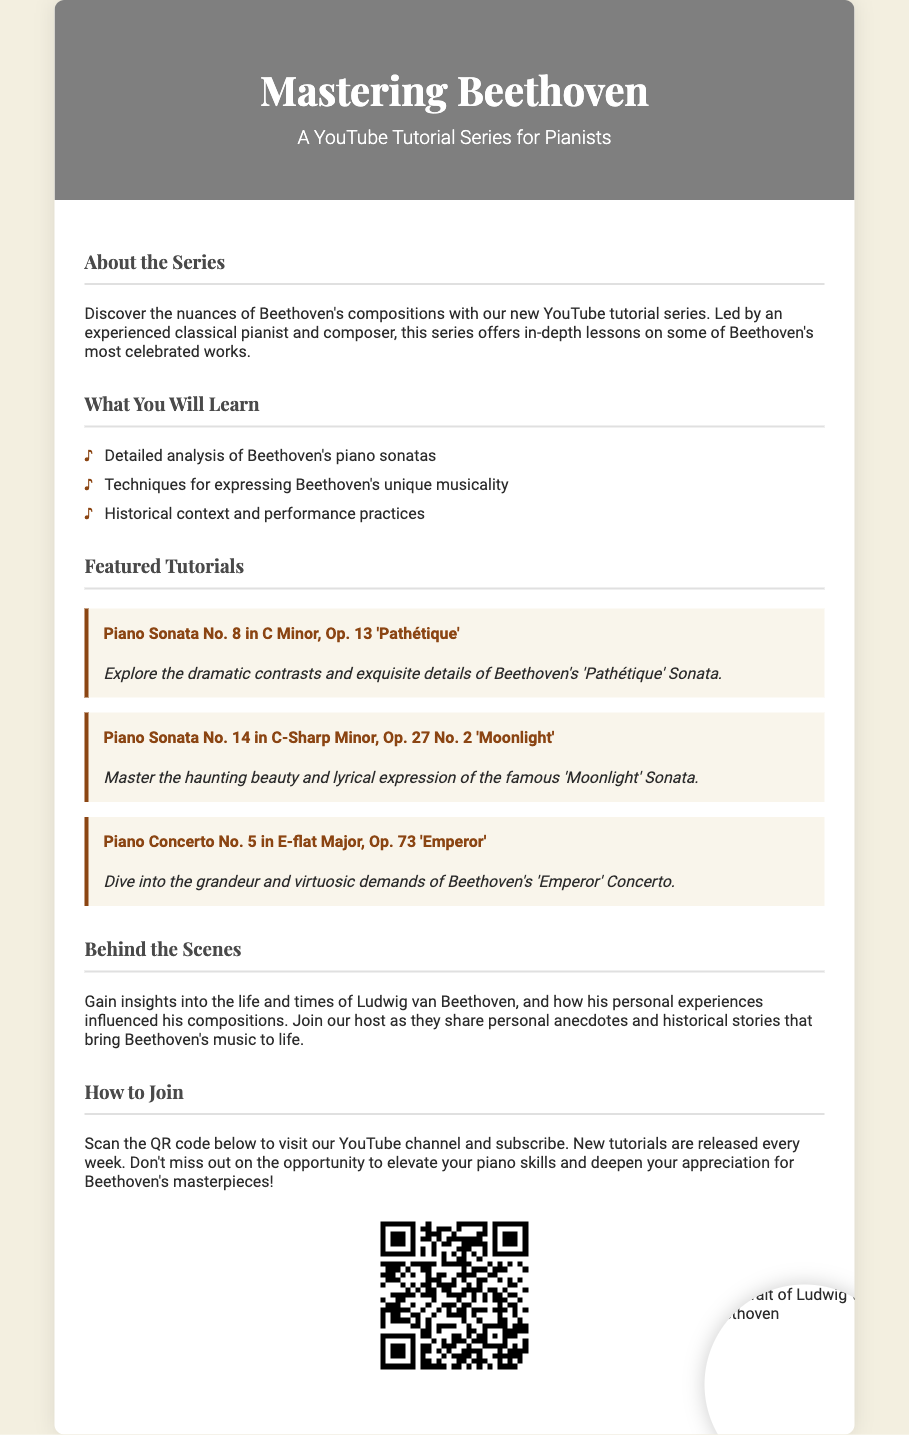What is the title of the tutorial series? The title is prominently displayed in the header section of the flyer.
Answer: Mastering Beethoven Who is the target audience for the series? The introductory text specifies who the tutorials are designed for.
Answer: Pianists How many featured tutorials are listed? The section on featured tutorials provides a clear list of how many are included.
Answer: Three What is the subtitle of the series? The subtitle is mentioned right below the title in the header.
Answer: A YouTube Tutorial Series for Pianists Where can viewers find the link to the tutorials? The flyer includes a QR code that leads to the relevant content.
Answer: QR code What is one of the pieces discussed in the featured tutorials? The featured tutorials section lists specific sonatas and concertos.
Answer: Piano Sonata No. 14 in C-Sharp Minor, Op. 27 No. 2 'Moonlight' How often are new tutorials released? The flyer mentions the frequency of the new content release in the "How to Join" section.
Answer: Every week What type of insights are shared in the "Behind the Scenes" section? This section describes the nature of insights provided in the series.
Answer: Personal anecdotes and historical stories 